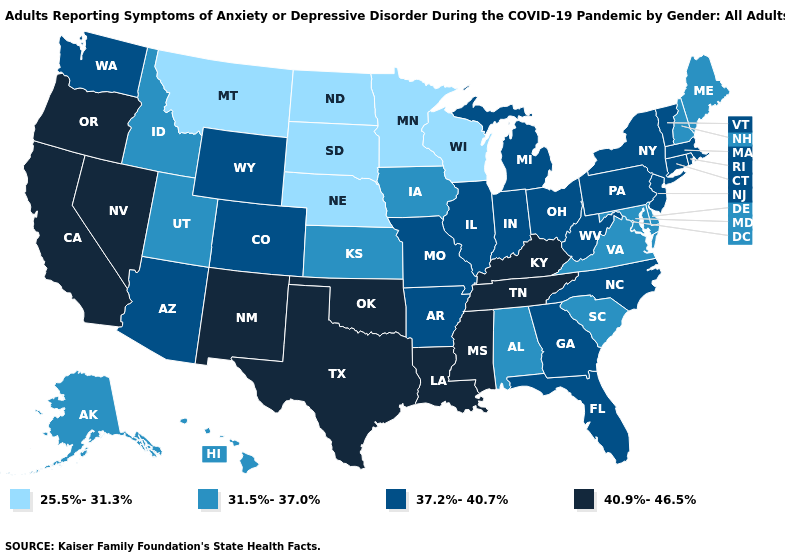Does the first symbol in the legend represent the smallest category?
Short answer required. Yes. Does the map have missing data?
Give a very brief answer. No. What is the value of Nebraska?
Short answer required. 25.5%-31.3%. What is the lowest value in the USA?
Give a very brief answer. 25.5%-31.3%. Among the states that border New Jersey , does New York have the lowest value?
Answer briefly. No. Among the states that border Idaho , does Washington have the highest value?
Give a very brief answer. No. Which states have the highest value in the USA?
Quick response, please. California, Kentucky, Louisiana, Mississippi, Nevada, New Mexico, Oklahoma, Oregon, Tennessee, Texas. What is the lowest value in the USA?
Be succinct. 25.5%-31.3%. Among the states that border Oklahoma , which have the lowest value?
Keep it brief. Kansas. What is the value of New Mexico?
Write a very short answer. 40.9%-46.5%. Name the states that have a value in the range 37.2%-40.7%?
Be succinct. Arizona, Arkansas, Colorado, Connecticut, Florida, Georgia, Illinois, Indiana, Massachusetts, Michigan, Missouri, New Jersey, New York, North Carolina, Ohio, Pennsylvania, Rhode Island, Vermont, Washington, West Virginia, Wyoming. What is the highest value in states that border New York?
Concise answer only. 37.2%-40.7%. What is the value of Kansas?
Quick response, please. 31.5%-37.0%. Which states have the lowest value in the USA?
Give a very brief answer. Minnesota, Montana, Nebraska, North Dakota, South Dakota, Wisconsin. What is the value of Massachusetts?
Write a very short answer. 37.2%-40.7%. 